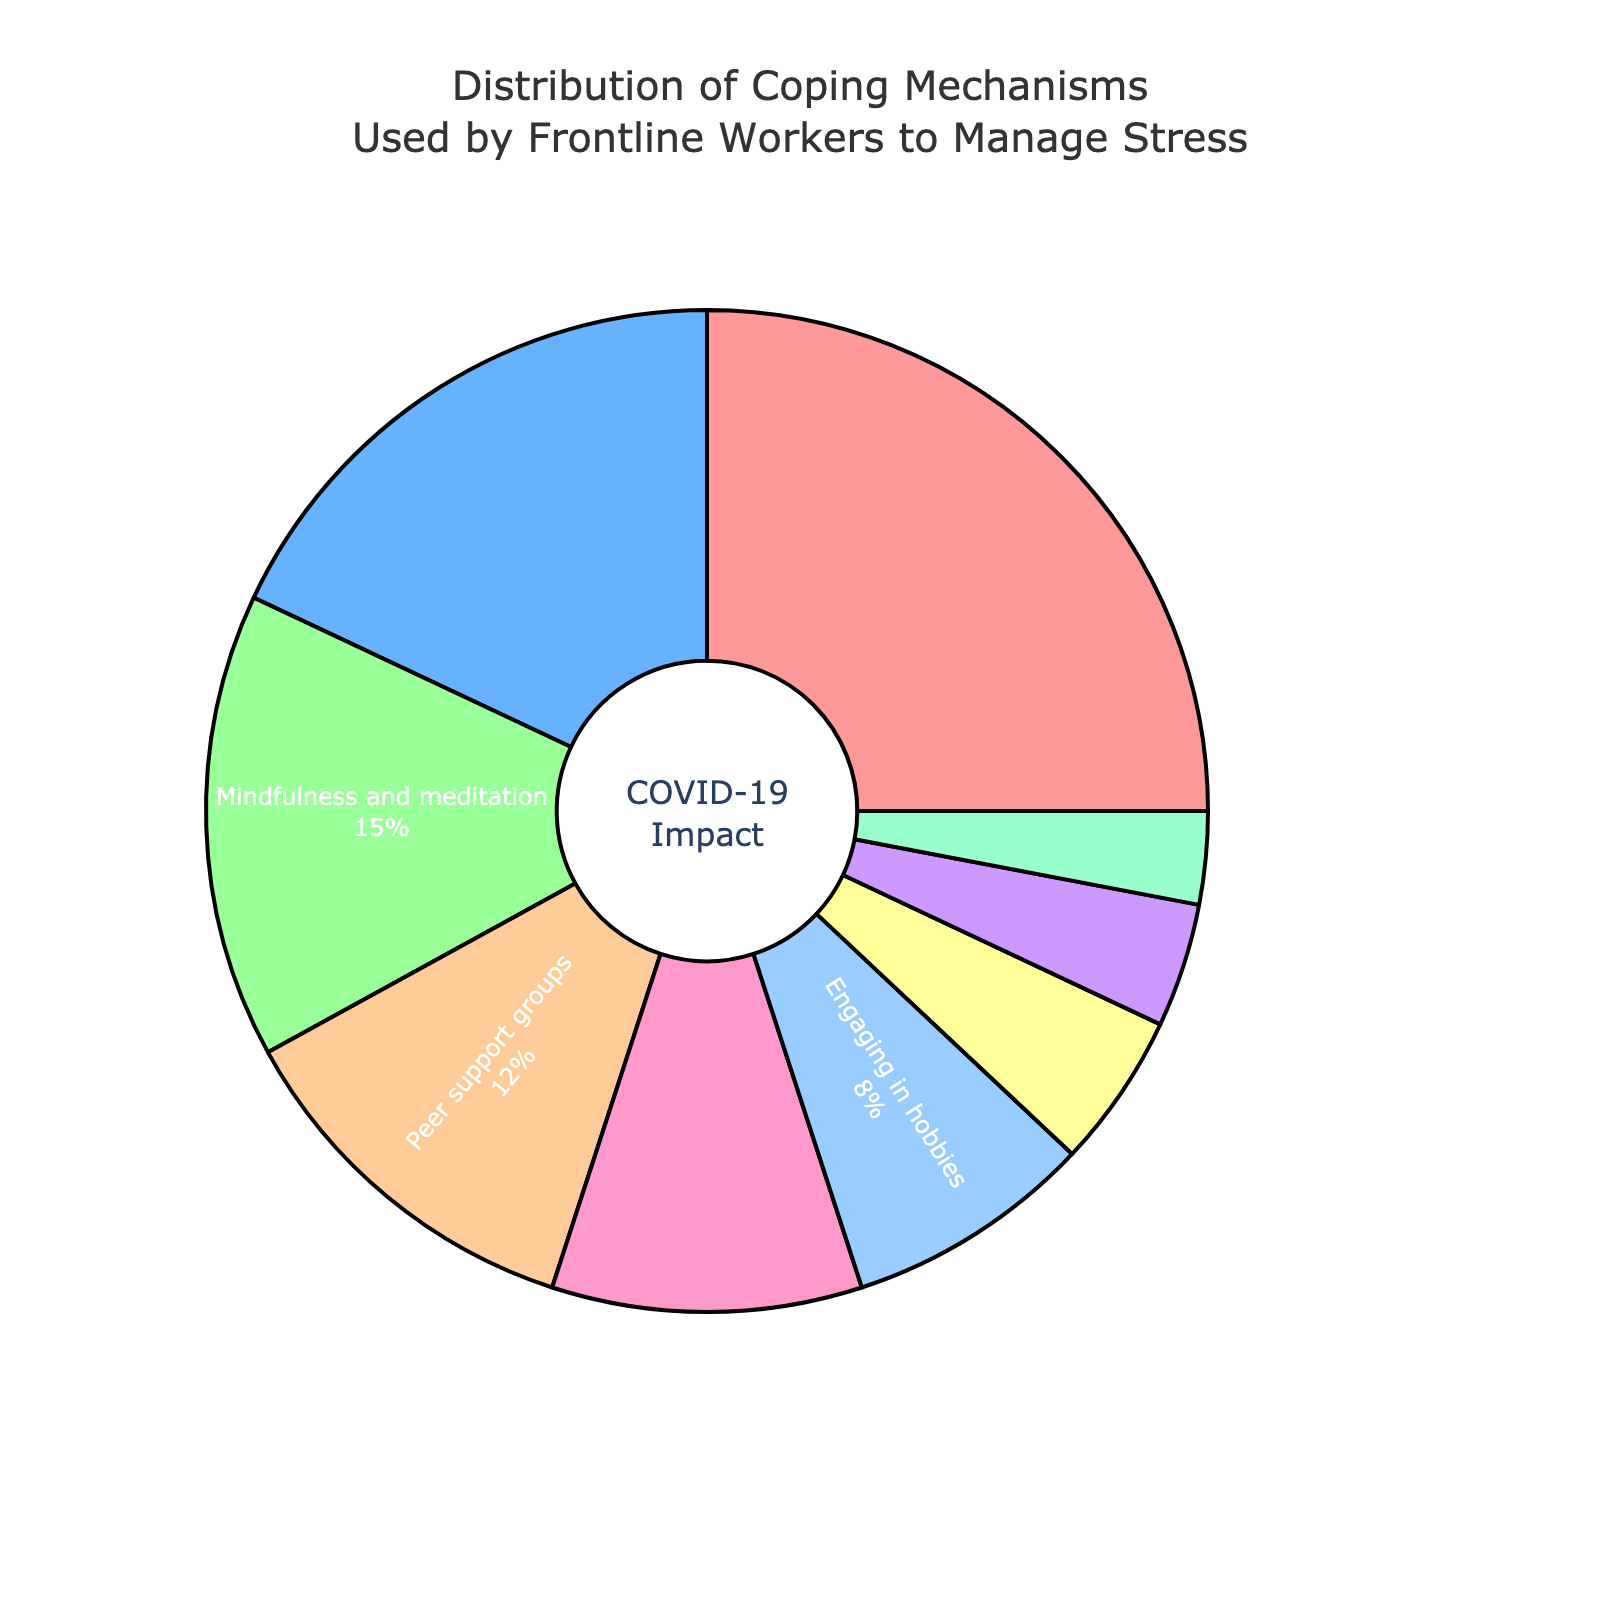Which coping mechanism has the highest percentage? The largest portion of the pie chart represents Exercise and physical activity.
Answer: Exercise and physical activity Which coping mechanism has the lowest percentage? The smallest portion of the pie chart represents Prayer or spiritual practices.
Answer: Prayer or spiritual practices What percentage of coping mechanisms is related to physical activities? Exercise and physical activity has a percentage of 25% in the pie chart.
Answer: 25% What is the combined percentage of mindfulness and engagement in hobbies? Mindfulness and meditation is 15% and Engaging in hobbies is 8%. The total is 15% + 8% = 23%.
Answer: 23% Which coping mechanism is more common, talking to a therapist or spending time with family and friends? The pie chart shows that Talking to a therapist or counselor is 18%, while Spending time with family and friends is 10%.
Answer: Talking to a therapist or counselor What is the difference in percentage between peer support groups and spending time with family and friends? The pie chart shows Peer support groups is 12% and Spending time with family and friends is 10%. The difference is 12% - 10% = 2%.
Answer: 2% Do more people use journaling or physical activity as a coping mechanism? The pie chart shows Exercise and physical activity is 25% and Journaling or expressive writing is 5%.
Answer: Exercise and physical activity Calculate the total percentage of coping mechanisms that involve social interaction. Talking to a therapist or counselor is 18%, Peer support groups is 12%, and Spending time with family and friends is 10%. The total is 18% + 12% + 10% = 40%.
Answer: 40% Which coping mechanisms cover more than 10% but less than 20% of usage? The pie chart shows Talking to a therapist or counselor is 18% and Mindfulness and meditation is 15%.
Answer: Talking to a therapist or counselor, Mindfulness and meditation If you combine taking breaks and journaling, will their combined percentage be more or less than prayer or spiritual practices? Taking breaks and time off work is 4%, Journaling or expressive writing is 5%, and Prayer or spiritual practices is 3%. The combined value of taking breaks and journaling is 4% + 5% = 9%, which is more than 3%.
Answer: More 